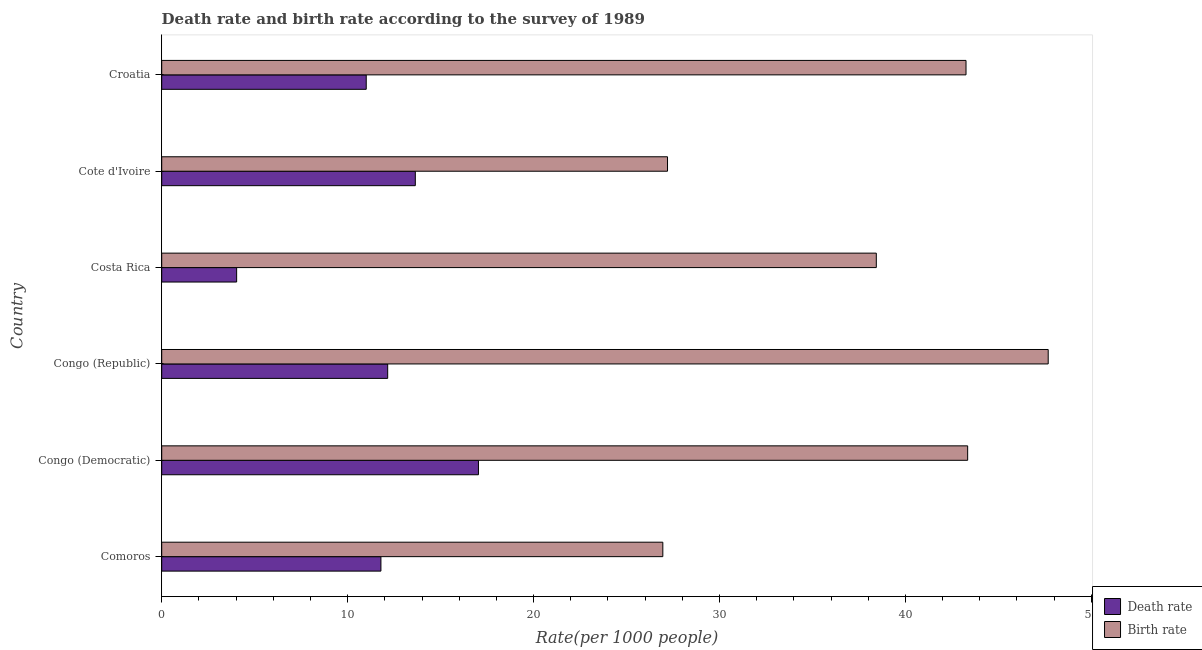How many different coloured bars are there?
Your answer should be compact. 2. How many bars are there on the 3rd tick from the top?
Make the answer very short. 2. How many bars are there on the 3rd tick from the bottom?
Make the answer very short. 2. What is the label of the 6th group of bars from the top?
Provide a succinct answer. Comoros. In how many cases, is the number of bars for a given country not equal to the number of legend labels?
Your answer should be compact. 0. What is the birth rate in Cote d'Ivoire?
Offer a terse response. 27.2. Across all countries, what is the maximum birth rate?
Ensure brevity in your answer.  47.68. Across all countries, what is the minimum death rate?
Your answer should be very brief. 4.03. In which country was the death rate maximum?
Offer a very short reply. Congo (Democratic). In which country was the birth rate minimum?
Keep it short and to the point. Comoros. What is the total death rate in the graph?
Keep it short and to the point. 69.65. What is the difference between the birth rate in Congo (Democratic) and that in Croatia?
Your answer should be compact. 0.09. What is the difference between the death rate in Croatia and the birth rate in Congo (Republic)?
Ensure brevity in your answer.  -36.68. What is the average birth rate per country?
Your answer should be compact. 37.81. What is the difference between the birth rate and death rate in Comoros?
Provide a short and direct response. 15.16. In how many countries, is the birth rate greater than 20 ?
Ensure brevity in your answer.  6. What is the ratio of the birth rate in Comoros to that in Cote d'Ivoire?
Offer a terse response. 0.99. What is the difference between the highest and the second highest birth rate?
Provide a short and direct response. 4.33. What is the difference between the highest and the lowest birth rate?
Provide a succinct answer. 20.73. In how many countries, is the birth rate greater than the average birth rate taken over all countries?
Provide a succinct answer. 4. What does the 2nd bar from the top in Croatia represents?
Provide a short and direct response. Death rate. What does the 2nd bar from the bottom in Croatia represents?
Offer a very short reply. Birth rate. Are all the bars in the graph horizontal?
Offer a terse response. Yes. How many countries are there in the graph?
Keep it short and to the point. 6. What is the difference between two consecutive major ticks on the X-axis?
Ensure brevity in your answer.  10. Where does the legend appear in the graph?
Your answer should be compact. Bottom right. How are the legend labels stacked?
Provide a short and direct response. Vertical. What is the title of the graph?
Provide a succinct answer. Death rate and birth rate according to the survey of 1989. Does "Money lenders" appear as one of the legend labels in the graph?
Your answer should be very brief. No. What is the label or title of the X-axis?
Offer a very short reply. Rate(per 1000 people). What is the label or title of the Y-axis?
Offer a terse response. Country. What is the Rate(per 1000 people) of Death rate in Comoros?
Your response must be concise. 11.79. What is the Rate(per 1000 people) in Birth rate in Comoros?
Provide a succinct answer. 26.95. What is the Rate(per 1000 people) of Death rate in Congo (Democratic)?
Provide a short and direct response. 17.04. What is the Rate(per 1000 people) in Birth rate in Congo (Democratic)?
Offer a terse response. 43.35. What is the Rate(per 1000 people) in Death rate in Congo (Republic)?
Ensure brevity in your answer.  12.15. What is the Rate(per 1000 people) of Birth rate in Congo (Republic)?
Offer a very short reply. 47.68. What is the Rate(per 1000 people) of Death rate in Costa Rica?
Give a very brief answer. 4.03. What is the Rate(per 1000 people) of Birth rate in Costa Rica?
Your answer should be compact. 38.43. What is the Rate(per 1000 people) of Death rate in Cote d'Ivoire?
Ensure brevity in your answer.  13.64. What is the Rate(per 1000 people) of Birth rate in Cote d'Ivoire?
Give a very brief answer. 27.2. What is the Rate(per 1000 people) of Birth rate in Croatia?
Give a very brief answer. 43.26. Across all countries, what is the maximum Rate(per 1000 people) of Death rate?
Provide a short and direct response. 17.04. Across all countries, what is the maximum Rate(per 1000 people) of Birth rate?
Ensure brevity in your answer.  47.68. Across all countries, what is the minimum Rate(per 1000 people) in Death rate?
Give a very brief answer. 4.03. Across all countries, what is the minimum Rate(per 1000 people) of Birth rate?
Provide a short and direct response. 26.95. What is the total Rate(per 1000 people) in Death rate in the graph?
Offer a terse response. 69.65. What is the total Rate(per 1000 people) of Birth rate in the graph?
Your response must be concise. 226.88. What is the difference between the Rate(per 1000 people) in Death rate in Comoros and that in Congo (Democratic)?
Give a very brief answer. -5.25. What is the difference between the Rate(per 1000 people) in Birth rate in Comoros and that in Congo (Democratic)?
Your response must be concise. -16.39. What is the difference between the Rate(per 1000 people) of Death rate in Comoros and that in Congo (Republic)?
Give a very brief answer. -0.36. What is the difference between the Rate(per 1000 people) in Birth rate in Comoros and that in Congo (Republic)?
Provide a short and direct response. -20.73. What is the difference between the Rate(per 1000 people) in Death rate in Comoros and that in Costa Rica?
Offer a terse response. 7.76. What is the difference between the Rate(per 1000 people) in Birth rate in Comoros and that in Costa Rica?
Provide a succinct answer. -11.48. What is the difference between the Rate(per 1000 people) of Death rate in Comoros and that in Cote d'Ivoire?
Provide a short and direct response. -1.85. What is the difference between the Rate(per 1000 people) in Birth rate in Comoros and that in Cote d'Ivoire?
Ensure brevity in your answer.  -0.25. What is the difference between the Rate(per 1000 people) of Death rate in Comoros and that in Croatia?
Give a very brief answer. 0.79. What is the difference between the Rate(per 1000 people) of Birth rate in Comoros and that in Croatia?
Your answer should be compact. -16.31. What is the difference between the Rate(per 1000 people) in Death rate in Congo (Democratic) and that in Congo (Republic)?
Offer a terse response. 4.88. What is the difference between the Rate(per 1000 people) of Birth rate in Congo (Democratic) and that in Congo (Republic)?
Give a very brief answer. -4.33. What is the difference between the Rate(per 1000 people) in Death rate in Congo (Democratic) and that in Costa Rica?
Your answer should be very brief. 13.01. What is the difference between the Rate(per 1000 people) of Birth rate in Congo (Democratic) and that in Costa Rica?
Offer a very short reply. 4.91. What is the difference between the Rate(per 1000 people) of Death rate in Congo (Democratic) and that in Cote d'Ivoire?
Provide a succinct answer. 3.4. What is the difference between the Rate(per 1000 people) of Birth rate in Congo (Democratic) and that in Cote d'Ivoire?
Offer a very short reply. 16.14. What is the difference between the Rate(per 1000 people) of Death rate in Congo (Democratic) and that in Croatia?
Your response must be concise. 6.04. What is the difference between the Rate(per 1000 people) in Birth rate in Congo (Democratic) and that in Croatia?
Ensure brevity in your answer.  0.09. What is the difference between the Rate(per 1000 people) of Death rate in Congo (Republic) and that in Costa Rica?
Give a very brief answer. 8.12. What is the difference between the Rate(per 1000 people) in Birth rate in Congo (Republic) and that in Costa Rica?
Ensure brevity in your answer.  9.24. What is the difference between the Rate(per 1000 people) of Death rate in Congo (Republic) and that in Cote d'Ivoire?
Provide a short and direct response. -1.49. What is the difference between the Rate(per 1000 people) of Birth rate in Congo (Republic) and that in Cote d'Ivoire?
Offer a terse response. 20.48. What is the difference between the Rate(per 1000 people) of Death rate in Congo (Republic) and that in Croatia?
Make the answer very short. 1.15. What is the difference between the Rate(per 1000 people) in Birth rate in Congo (Republic) and that in Croatia?
Ensure brevity in your answer.  4.42. What is the difference between the Rate(per 1000 people) of Death rate in Costa Rica and that in Cote d'Ivoire?
Your answer should be very brief. -9.61. What is the difference between the Rate(per 1000 people) in Birth rate in Costa Rica and that in Cote d'Ivoire?
Keep it short and to the point. 11.23. What is the difference between the Rate(per 1000 people) of Death rate in Costa Rica and that in Croatia?
Provide a succinct answer. -6.97. What is the difference between the Rate(per 1000 people) of Birth rate in Costa Rica and that in Croatia?
Give a very brief answer. -4.83. What is the difference between the Rate(per 1000 people) in Death rate in Cote d'Ivoire and that in Croatia?
Give a very brief answer. 2.64. What is the difference between the Rate(per 1000 people) in Birth rate in Cote d'Ivoire and that in Croatia?
Provide a succinct answer. -16.05. What is the difference between the Rate(per 1000 people) in Death rate in Comoros and the Rate(per 1000 people) in Birth rate in Congo (Democratic)?
Your answer should be very brief. -31.56. What is the difference between the Rate(per 1000 people) in Death rate in Comoros and the Rate(per 1000 people) in Birth rate in Congo (Republic)?
Ensure brevity in your answer.  -35.89. What is the difference between the Rate(per 1000 people) of Death rate in Comoros and the Rate(per 1000 people) of Birth rate in Costa Rica?
Provide a succinct answer. -26.64. What is the difference between the Rate(per 1000 people) in Death rate in Comoros and the Rate(per 1000 people) in Birth rate in Cote d'Ivoire?
Provide a succinct answer. -15.41. What is the difference between the Rate(per 1000 people) of Death rate in Comoros and the Rate(per 1000 people) of Birth rate in Croatia?
Your answer should be compact. -31.47. What is the difference between the Rate(per 1000 people) in Death rate in Congo (Democratic) and the Rate(per 1000 people) in Birth rate in Congo (Republic)?
Offer a very short reply. -30.64. What is the difference between the Rate(per 1000 people) in Death rate in Congo (Democratic) and the Rate(per 1000 people) in Birth rate in Costa Rica?
Ensure brevity in your answer.  -21.4. What is the difference between the Rate(per 1000 people) in Death rate in Congo (Democratic) and the Rate(per 1000 people) in Birth rate in Cote d'Ivoire?
Make the answer very short. -10.17. What is the difference between the Rate(per 1000 people) in Death rate in Congo (Democratic) and the Rate(per 1000 people) in Birth rate in Croatia?
Your response must be concise. -26.22. What is the difference between the Rate(per 1000 people) of Death rate in Congo (Republic) and the Rate(per 1000 people) of Birth rate in Costa Rica?
Give a very brief answer. -26.28. What is the difference between the Rate(per 1000 people) of Death rate in Congo (Republic) and the Rate(per 1000 people) of Birth rate in Cote d'Ivoire?
Your response must be concise. -15.05. What is the difference between the Rate(per 1000 people) in Death rate in Congo (Republic) and the Rate(per 1000 people) in Birth rate in Croatia?
Your answer should be compact. -31.11. What is the difference between the Rate(per 1000 people) of Death rate in Costa Rica and the Rate(per 1000 people) of Birth rate in Cote d'Ivoire?
Keep it short and to the point. -23.17. What is the difference between the Rate(per 1000 people) of Death rate in Costa Rica and the Rate(per 1000 people) of Birth rate in Croatia?
Offer a terse response. -39.23. What is the difference between the Rate(per 1000 people) of Death rate in Cote d'Ivoire and the Rate(per 1000 people) of Birth rate in Croatia?
Your response must be concise. -29.62. What is the average Rate(per 1000 people) of Death rate per country?
Ensure brevity in your answer.  11.61. What is the average Rate(per 1000 people) in Birth rate per country?
Your response must be concise. 37.81. What is the difference between the Rate(per 1000 people) of Death rate and Rate(per 1000 people) of Birth rate in Comoros?
Give a very brief answer. -15.16. What is the difference between the Rate(per 1000 people) of Death rate and Rate(per 1000 people) of Birth rate in Congo (Democratic)?
Offer a very short reply. -26.31. What is the difference between the Rate(per 1000 people) in Death rate and Rate(per 1000 people) in Birth rate in Congo (Republic)?
Give a very brief answer. -35.52. What is the difference between the Rate(per 1000 people) in Death rate and Rate(per 1000 people) in Birth rate in Costa Rica?
Provide a succinct answer. -34.4. What is the difference between the Rate(per 1000 people) in Death rate and Rate(per 1000 people) in Birth rate in Cote d'Ivoire?
Offer a terse response. -13.56. What is the difference between the Rate(per 1000 people) of Death rate and Rate(per 1000 people) of Birth rate in Croatia?
Your answer should be very brief. -32.26. What is the ratio of the Rate(per 1000 people) of Death rate in Comoros to that in Congo (Democratic)?
Provide a succinct answer. 0.69. What is the ratio of the Rate(per 1000 people) of Birth rate in Comoros to that in Congo (Democratic)?
Your response must be concise. 0.62. What is the ratio of the Rate(per 1000 people) of Death rate in Comoros to that in Congo (Republic)?
Ensure brevity in your answer.  0.97. What is the ratio of the Rate(per 1000 people) in Birth rate in Comoros to that in Congo (Republic)?
Your answer should be very brief. 0.57. What is the ratio of the Rate(per 1000 people) of Death rate in Comoros to that in Costa Rica?
Make the answer very short. 2.93. What is the ratio of the Rate(per 1000 people) in Birth rate in Comoros to that in Costa Rica?
Your answer should be very brief. 0.7. What is the ratio of the Rate(per 1000 people) in Death rate in Comoros to that in Cote d'Ivoire?
Your answer should be very brief. 0.86. What is the ratio of the Rate(per 1000 people) of Death rate in Comoros to that in Croatia?
Your answer should be very brief. 1.07. What is the ratio of the Rate(per 1000 people) in Birth rate in Comoros to that in Croatia?
Provide a succinct answer. 0.62. What is the ratio of the Rate(per 1000 people) of Death rate in Congo (Democratic) to that in Congo (Republic)?
Offer a terse response. 1.4. What is the ratio of the Rate(per 1000 people) of Birth rate in Congo (Democratic) to that in Congo (Republic)?
Offer a terse response. 0.91. What is the ratio of the Rate(per 1000 people) of Death rate in Congo (Democratic) to that in Costa Rica?
Your response must be concise. 4.23. What is the ratio of the Rate(per 1000 people) in Birth rate in Congo (Democratic) to that in Costa Rica?
Your answer should be compact. 1.13. What is the ratio of the Rate(per 1000 people) of Death rate in Congo (Democratic) to that in Cote d'Ivoire?
Offer a terse response. 1.25. What is the ratio of the Rate(per 1000 people) in Birth rate in Congo (Democratic) to that in Cote d'Ivoire?
Provide a succinct answer. 1.59. What is the ratio of the Rate(per 1000 people) in Death rate in Congo (Democratic) to that in Croatia?
Offer a very short reply. 1.55. What is the ratio of the Rate(per 1000 people) in Death rate in Congo (Republic) to that in Costa Rica?
Give a very brief answer. 3.02. What is the ratio of the Rate(per 1000 people) of Birth rate in Congo (Republic) to that in Costa Rica?
Your answer should be compact. 1.24. What is the ratio of the Rate(per 1000 people) of Death rate in Congo (Republic) to that in Cote d'Ivoire?
Ensure brevity in your answer.  0.89. What is the ratio of the Rate(per 1000 people) in Birth rate in Congo (Republic) to that in Cote d'Ivoire?
Keep it short and to the point. 1.75. What is the ratio of the Rate(per 1000 people) of Death rate in Congo (Republic) to that in Croatia?
Your answer should be compact. 1.1. What is the ratio of the Rate(per 1000 people) of Birth rate in Congo (Republic) to that in Croatia?
Make the answer very short. 1.1. What is the ratio of the Rate(per 1000 people) of Death rate in Costa Rica to that in Cote d'Ivoire?
Your answer should be very brief. 0.3. What is the ratio of the Rate(per 1000 people) in Birth rate in Costa Rica to that in Cote d'Ivoire?
Your response must be concise. 1.41. What is the ratio of the Rate(per 1000 people) in Death rate in Costa Rica to that in Croatia?
Your response must be concise. 0.37. What is the ratio of the Rate(per 1000 people) in Birth rate in Costa Rica to that in Croatia?
Your answer should be very brief. 0.89. What is the ratio of the Rate(per 1000 people) of Death rate in Cote d'Ivoire to that in Croatia?
Provide a short and direct response. 1.24. What is the ratio of the Rate(per 1000 people) in Birth rate in Cote d'Ivoire to that in Croatia?
Offer a very short reply. 0.63. What is the difference between the highest and the second highest Rate(per 1000 people) in Death rate?
Your answer should be very brief. 3.4. What is the difference between the highest and the second highest Rate(per 1000 people) of Birth rate?
Make the answer very short. 4.33. What is the difference between the highest and the lowest Rate(per 1000 people) of Death rate?
Your response must be concise. 13.01. What is the difference between the highest and the lowest Rate(per 1000 people) in Birth rate?
Ensure brevity in your answer.  20.73. 